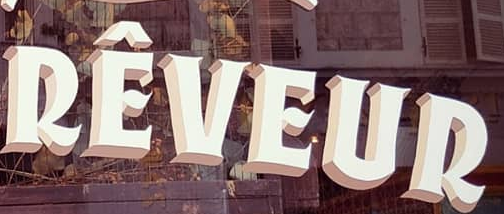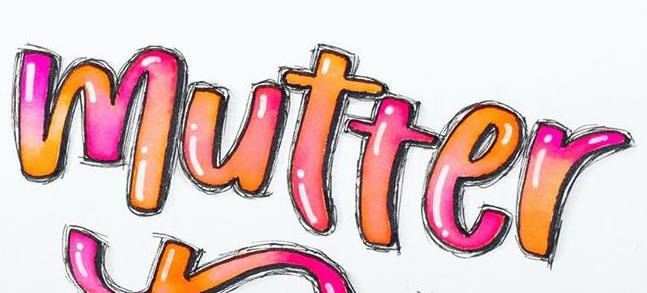Transcribe the words shown in these images in order, separated by a semicolon. RÊVEUR; mutter 